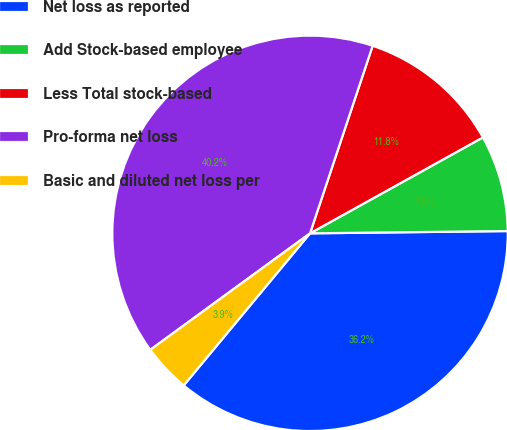<chart> <loc_0><loc_0><loc_500><loc_500><pie_chart><fcel>Net loss as reported<fcel>Add Stock-based employee<fcel>Less Total stock-based<fcel>Pro-forma net loss<fcel>Basic and diluted net loss per<nl><fcel>36.22%<fcel>7.88%<fcel>11.81%<fcel>40.16%<fcel>3.94%<nl></chart> 